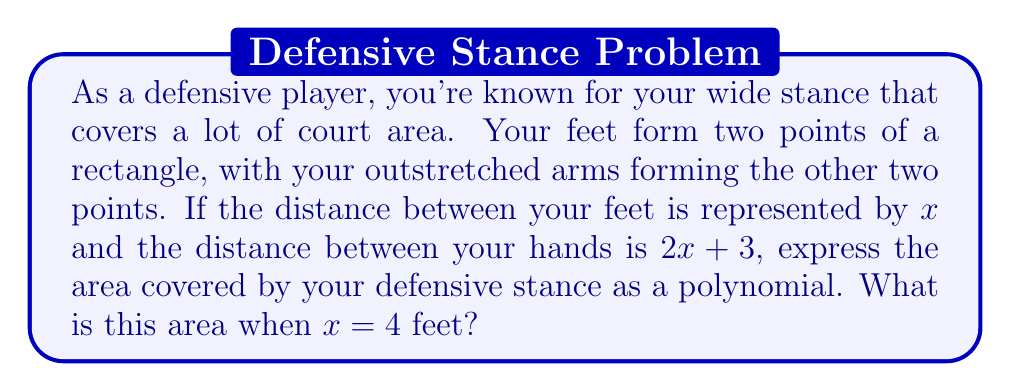Help me with this question. Let's approach this step-by-step:

1) The defensive stance forms a rectangle. The area of a rectangle is given by length × width.

2) The width of the rectangle is the distance between your feet, which is given as $x$.

3) The length of the rectangle is the distance between your hands, which is given as $2x+3$.

4) Therefore, the area $A$ can be expressed as:

   $A = x(2x+3)$

5) Expanding this polynomial:

   $A = 2x^2 + 3x$

6) This is our polynomial expression for the area.

7) To find the area when $x=4$ feet, we substitute this value into our expression:

   $A = 2(4)^2 + 3(4)$
   $= 2(16) + 12$
   $= 32 + 12$
   $= 44$

Therefore, when $x=4$ feet, the area covered by your defensive stance is 44 square feet.
Answer: The area covered by the defensive stance is $2x^2 + 3x$ square feet. When $x=4$ feet, the area is 44 square feet. 